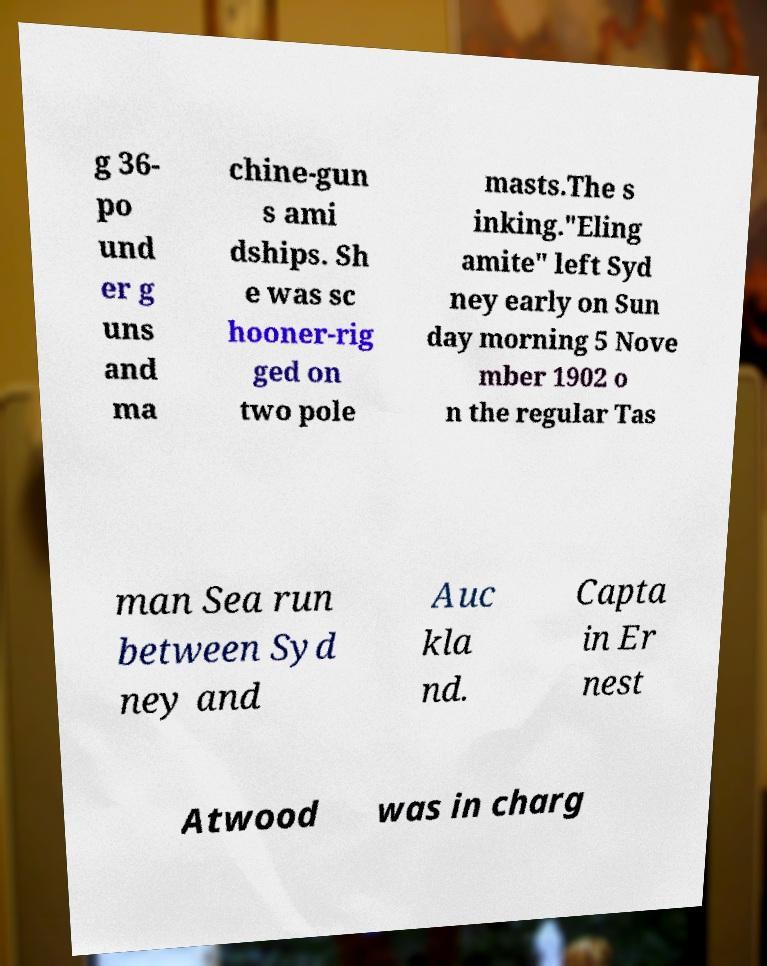There's text embedded in this image that I need extracted. Can you transcribe it verbatim? g 36- po und er g uns and ma chine-gun s ami dships. Sh e was sc hooner-rig ged on two pole masts.The s inking."Eling amite" left Syd ney early on Sun day morning 5 Nove mber 1902 o n the regular Tas man Sea run between Syd ney and Auc kla nd. Capta in Er nest Atwood was in charg 